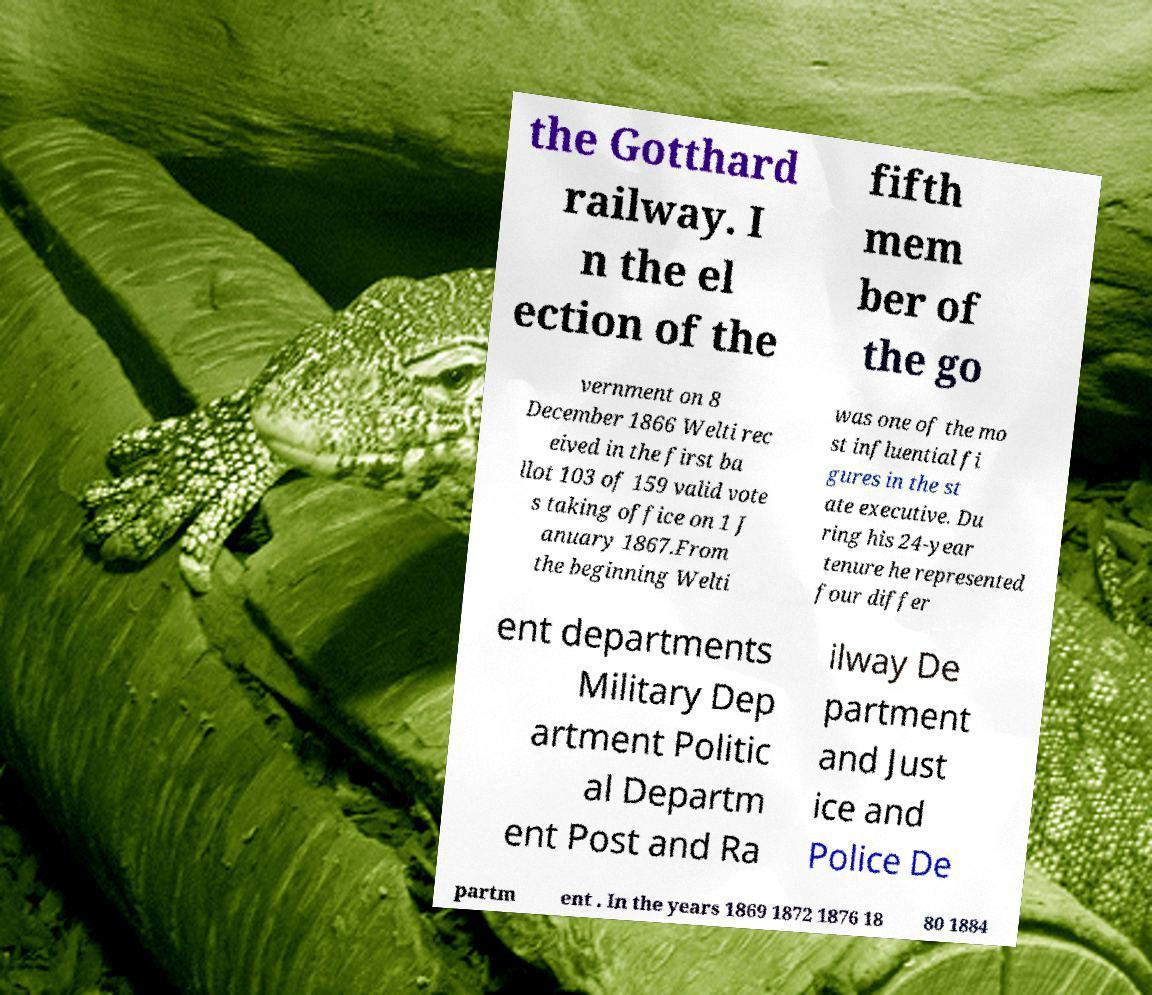I need the written content from this picture converted into text. Can you do that? the Gotthard railway. I n the el ection of the fifth mem ber of the go vernment on 8 December 1866 Welti rec eived in the first ba llot 103 of 159 valid vote s taking office on 1 J anuary 1867.From the beginning Welti was one of the mo st influential fi gures in the st ate executive. Du ring his 24-year tenure he represented four differ ent departments Military Dep artment Politic al Departm ent Post and Ra ilway De partment and Just ice and Police De partm ent . In the years 1869 1872 1876 18 80 1884 